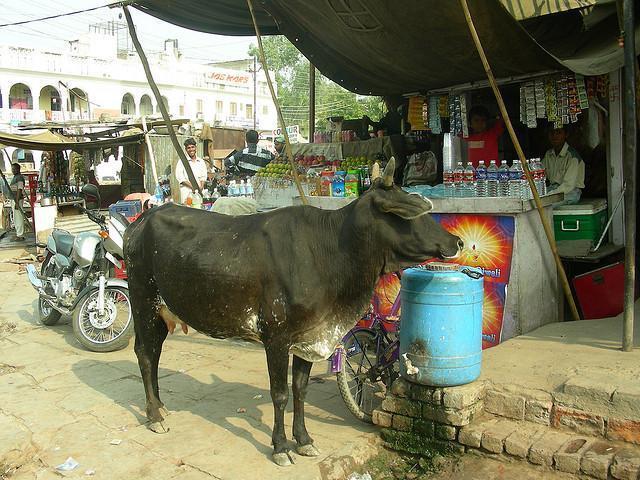Is "The cow is in front of the bicycle." an appropriate description for the image?
Answer yes or no. Yes. 